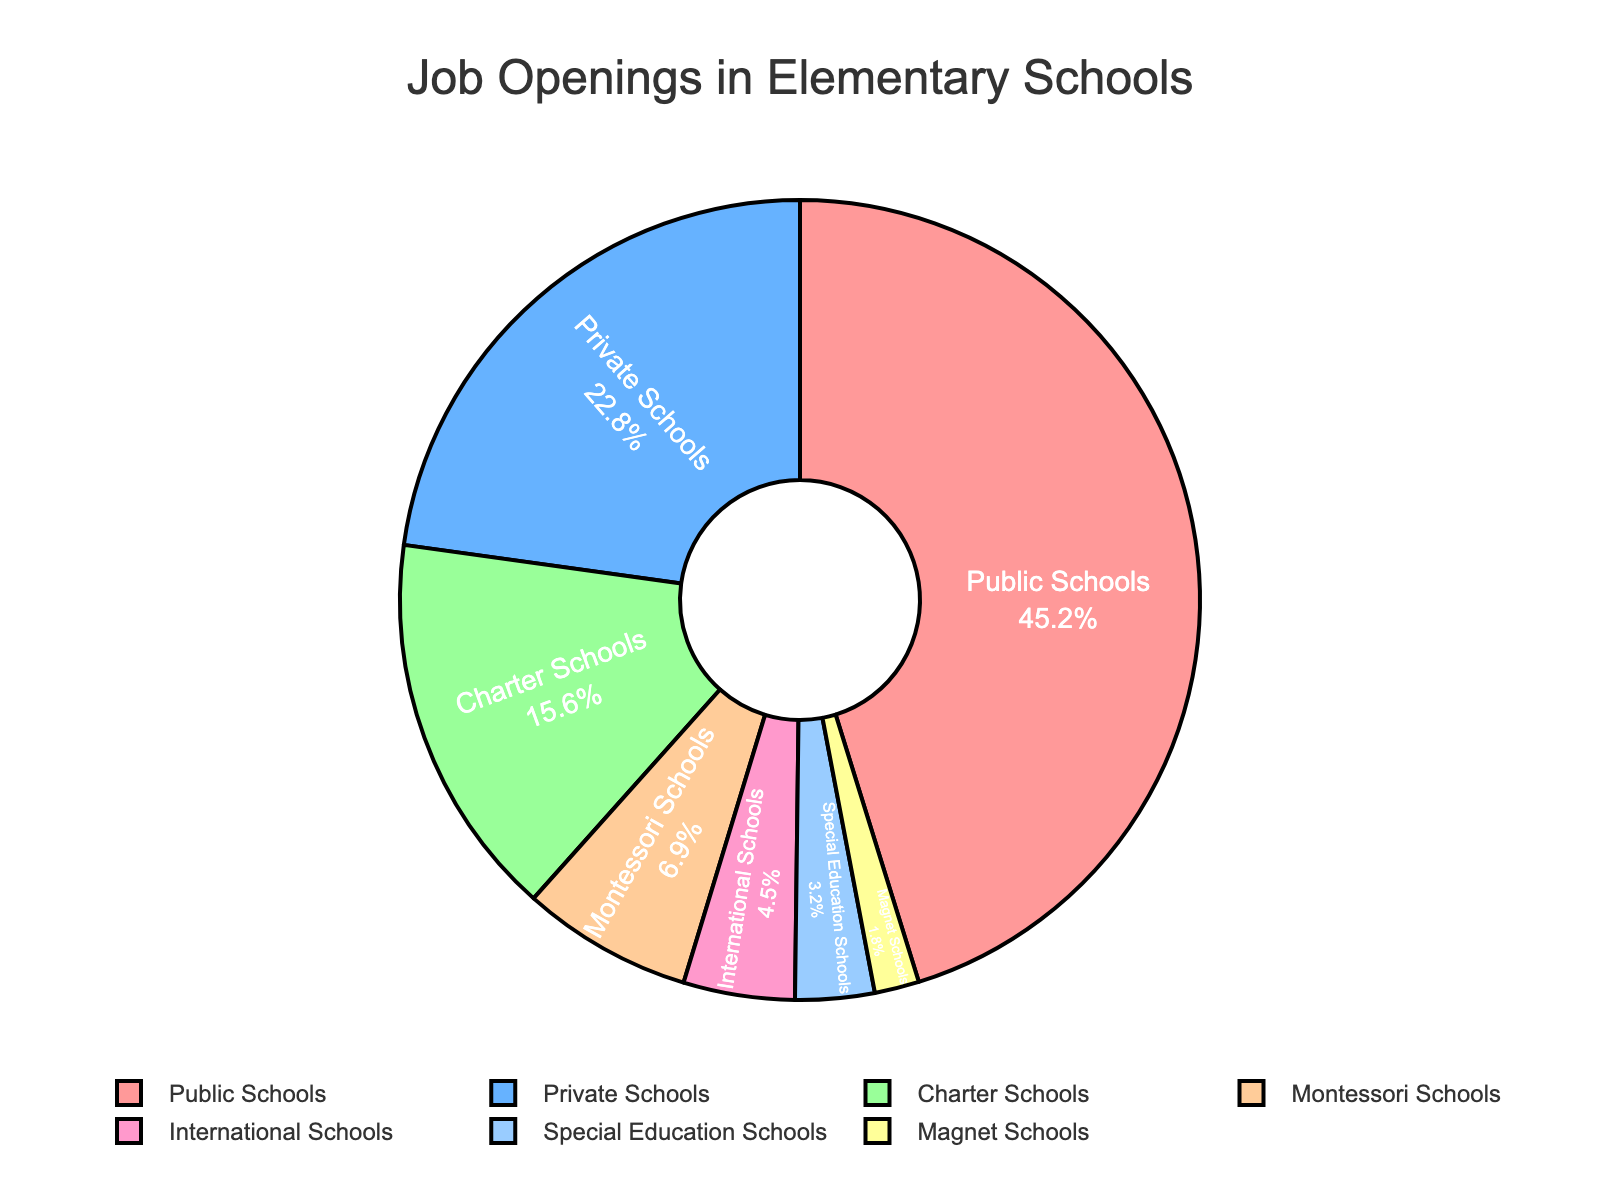What percentage of job openings are in Public Schools? Look at the pie chart segment labeled "Public Schools" to find the percentage of job openings.
Answer: 45.2% Which type of school has the least job openings? Identify the smallest segment on the pie chart which represents the school with the least job openings. The label on this segment is "Magnet Schools."
Answer: Magnet Schools Are there more job openings in Private Schools or Charter Schools? Compare the segments labeled "Private Schools" with "Charter Schools." The percentage for Private Schools is 22.8%, and for Charter Schools, it is 15.6%.
Answer: Private Schools What is the combined percentage of job openings in Montessori and International Schools? Add the percentages of Montessori Schools (6.9%) and International Schools (4.5%). The sum is 6.9 + 4.5.
Answer: 11.4% Which two types of schools together make up about 50% of all job openings? Look for two segments whose combined percentages are close to 50%. Adding the percentages for Public Schools (45.2%) and Magnet Schools (1.8%) gets close to 50%.
Answer: Public Schools and Magnet Schools How much larger is the percentage of job openings in Public Schools compared to Montessori Schools? Subtract the percentage of Montessori Schools (6.9%) from Public Schools (45.2%). The difference is 45.2 - 6.9.
Answer: 38.3% What percentage of job openings are in schools other than Public Schools? Subtract the percentage of Public Schools (45.2%) from 100%. Use 100 - 45.2 to find the total percentage for other schools.
Answer: 54.8% How does the proportion of job openings in Special Education Schools and International Schools compare? Compare the segments labeled "Special Education Schools" (3.2%) and "International Schools" (4.5%).
Answer: International Schools have more Is the job opening in International Schools smaller than that in Charter Schools? Compare the segments for International Schools (4.5%) and Charter Schools (15.6%).
Answer: Yes 